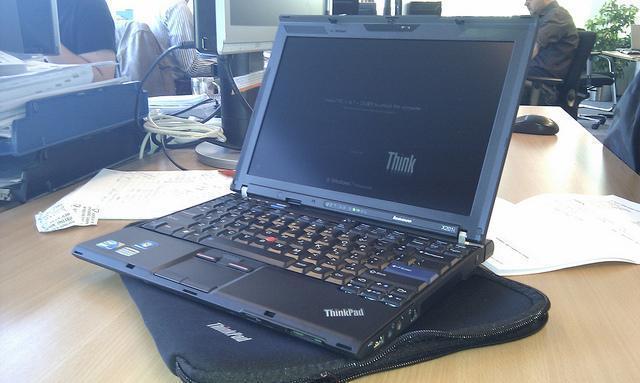What state is the computer most likely in?
Choose the right answer from the provided options to respond to the question.
Options: Off, starting up, at desktop, processing video. Starting up. 